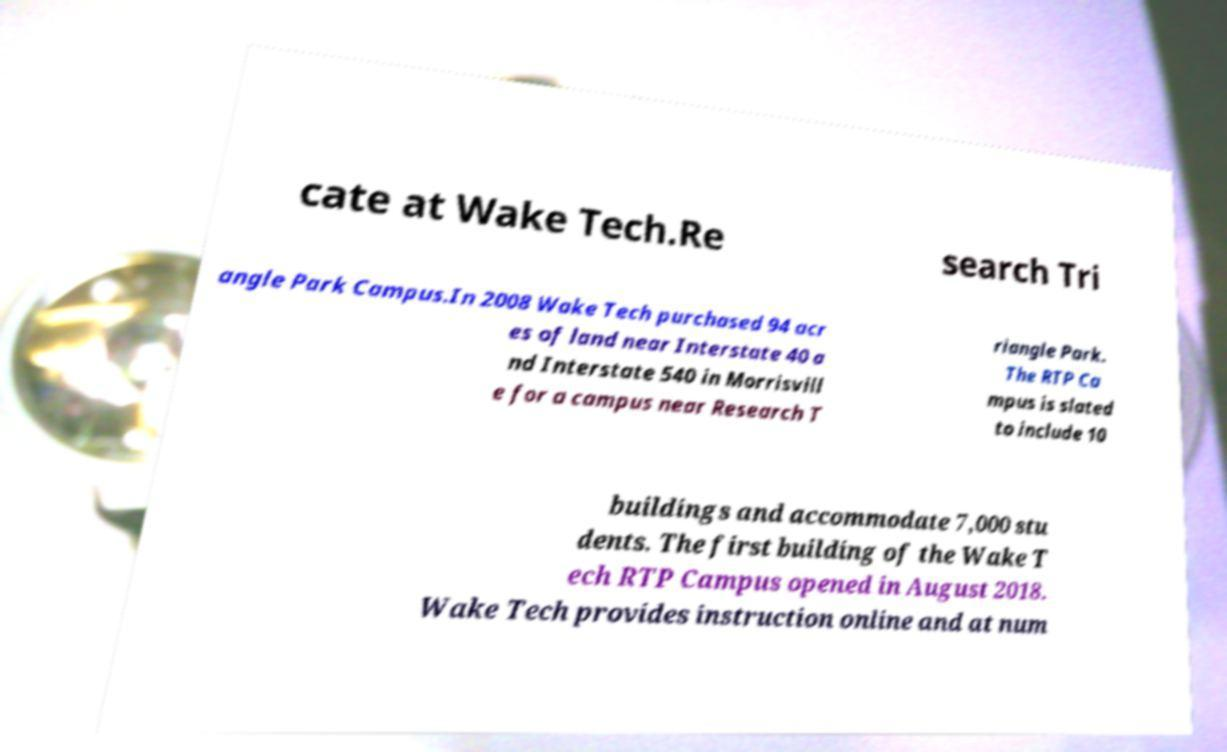For documentation purposes, I need the text within this image transcribed. Could you provide that? cate at Wake Tech.Re search Tri angle Park Campus.In 2008 Wake Tech purchased 94 acr es of land near Interstate 40 a nd Interstate 540 in Morrisvill e for a campus near Research T riangle Park. The RTP Ca mpus is slated to include 10 buildings and accommodate 7,000 stu dents. The first building of the Wake T ech RTP Campus opened in August 2018. Wake Tech provides instruction online and at num 